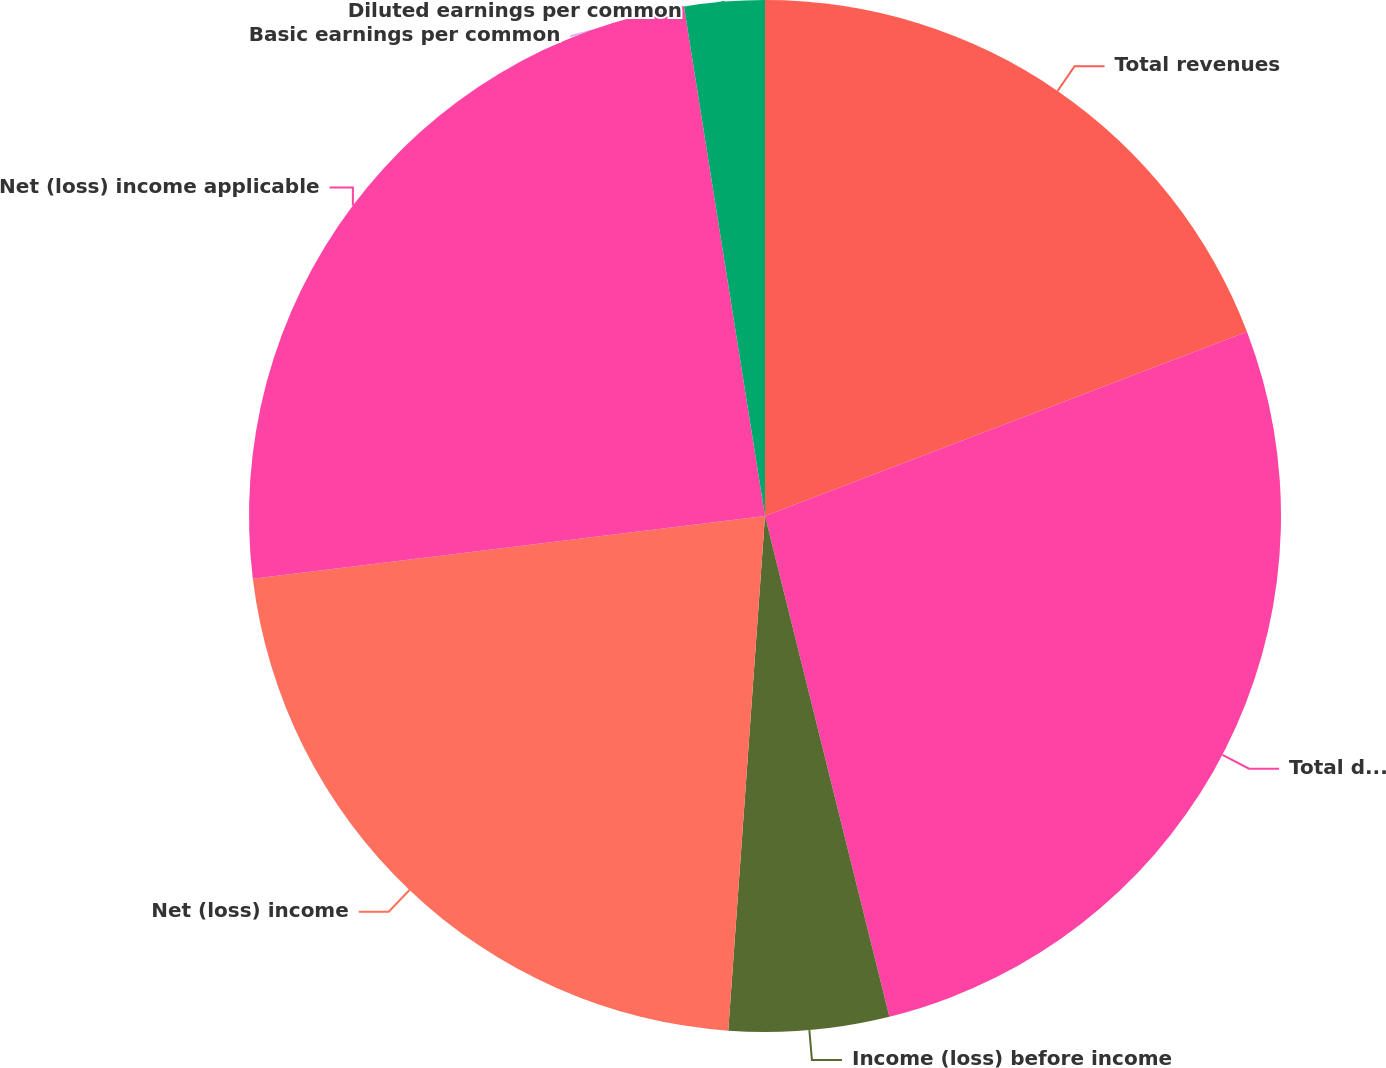Convert chart to OTSL. <chart><loc_0><loc_0><loc_500><loc_500><pie_chart><fcel>Total revenues<fcel>Total discontinued operations<fcel>Income (loss) before income<fcel>Net (loss) income<fcel>Net (loss) income applicable<fcel>Basic earnings per common<fcel>Diluted earnings per common<nl><fcel>19.19%<fcel>26.94%<fcel>5.01%<fcel>21.93%<fcel>24.43%<fcel>0.0%<fcel>2.51%<nl></chart> 